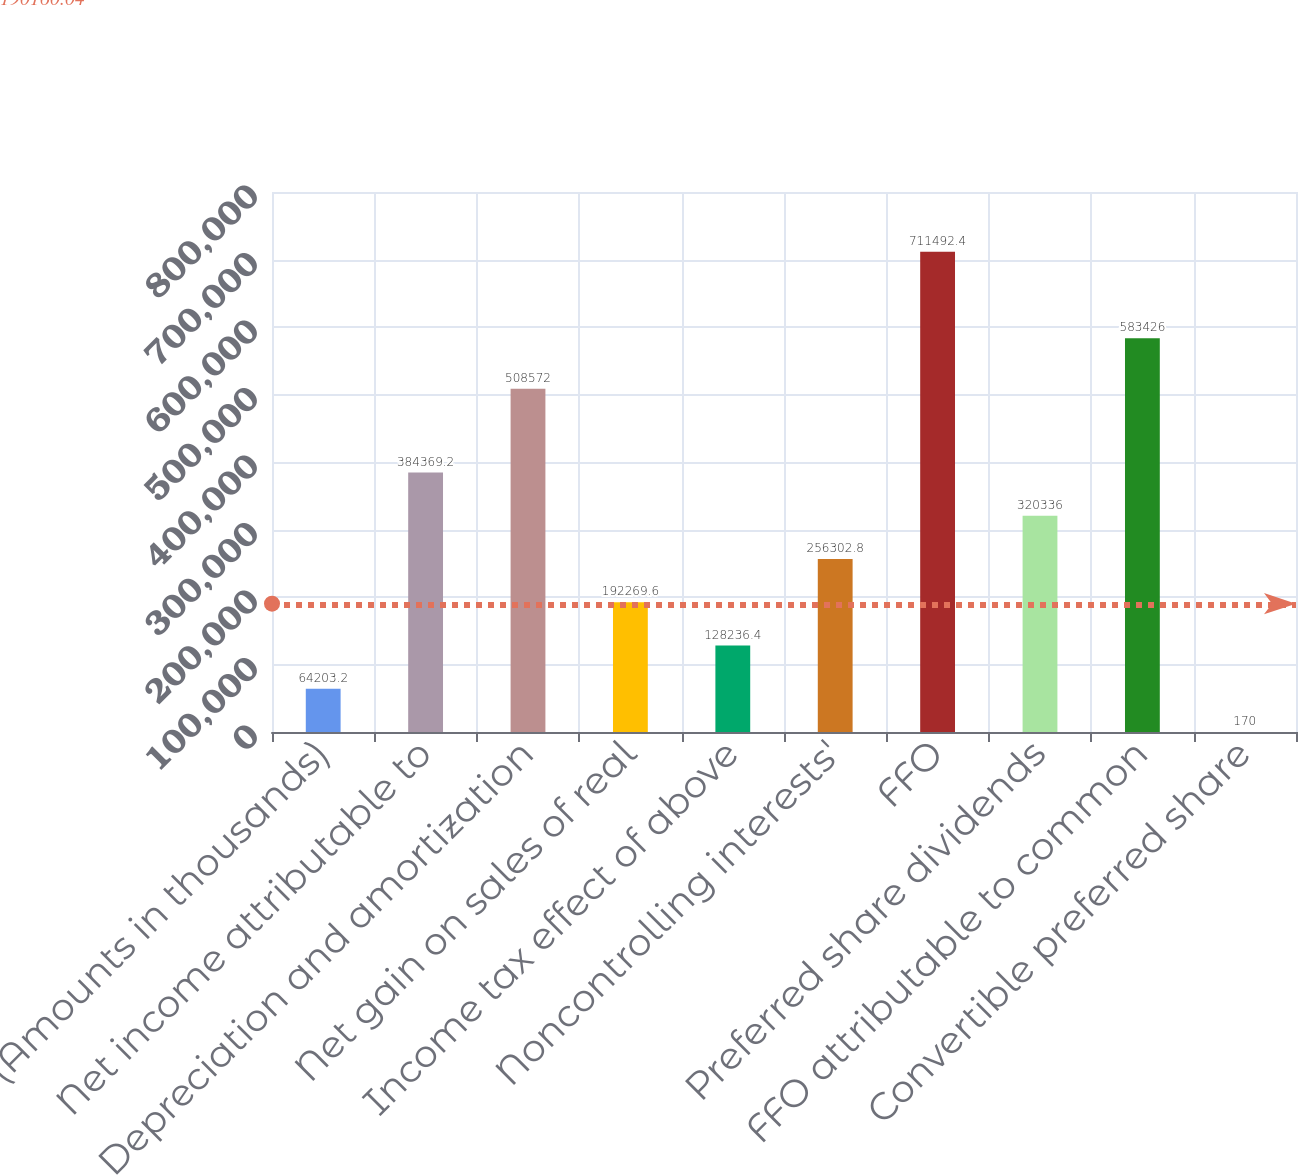<chart> <loc_0><loc_0><loc_500><loc_500><bar_chart><fcel>(Amounts in thousands)<fcel>Net income attributable to<fcel>Depreciation and amortization<fcel>Net gain on sales of real<fcel>Income tax effect of above<fcel>Noncontrolling interests'<fcel>FFO<fcel>Preferred share dividends<fcel>FFO attributable to common<fcel>Convertible preferred share<nl><fcel>64203.2<fcel>384369<fcel>508572<fcel>192270<fcel>128236<fcel>256303<fcel>711492<fcel>320336<fcel>583426<fcel>170<nl></chart> 